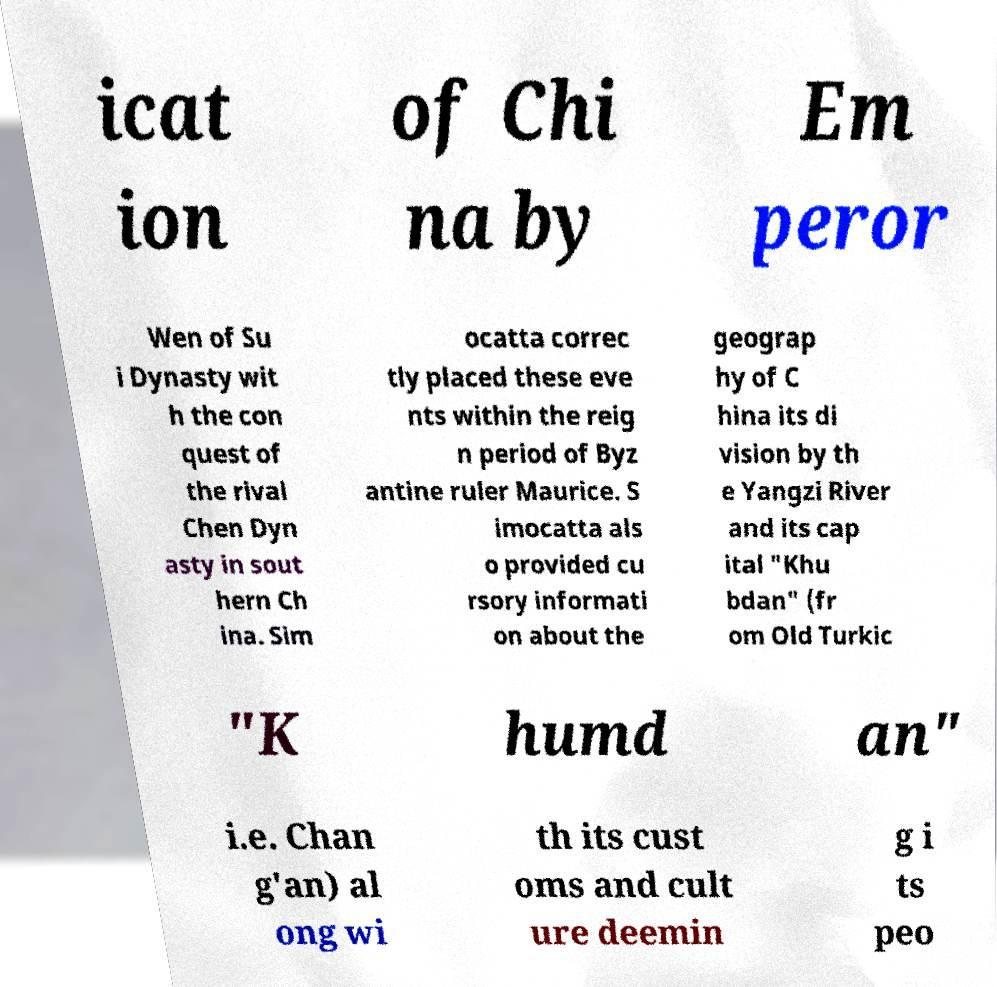Could you assist in decoding the text presented in this image and type it out clearly? icat ion of Chi na by Em peror Wen of Su i Dynasty wit h the con quest of the rival Chen Dyn asty in sout hern Ch ina. Sim ocatta correc tly placed these eve nts within the reig n period of Byz antine ruler Maurice. S imocatta als o provided cu rsory informati on about the geograp hy of C hina its di vision by th e Yangzi River and its cap ital "Khu bdan" (fr om Old Turkic "K humd an" i.e. Chan g'an) al ong wi th its cust oms and cult ure deemin g i ts peo 